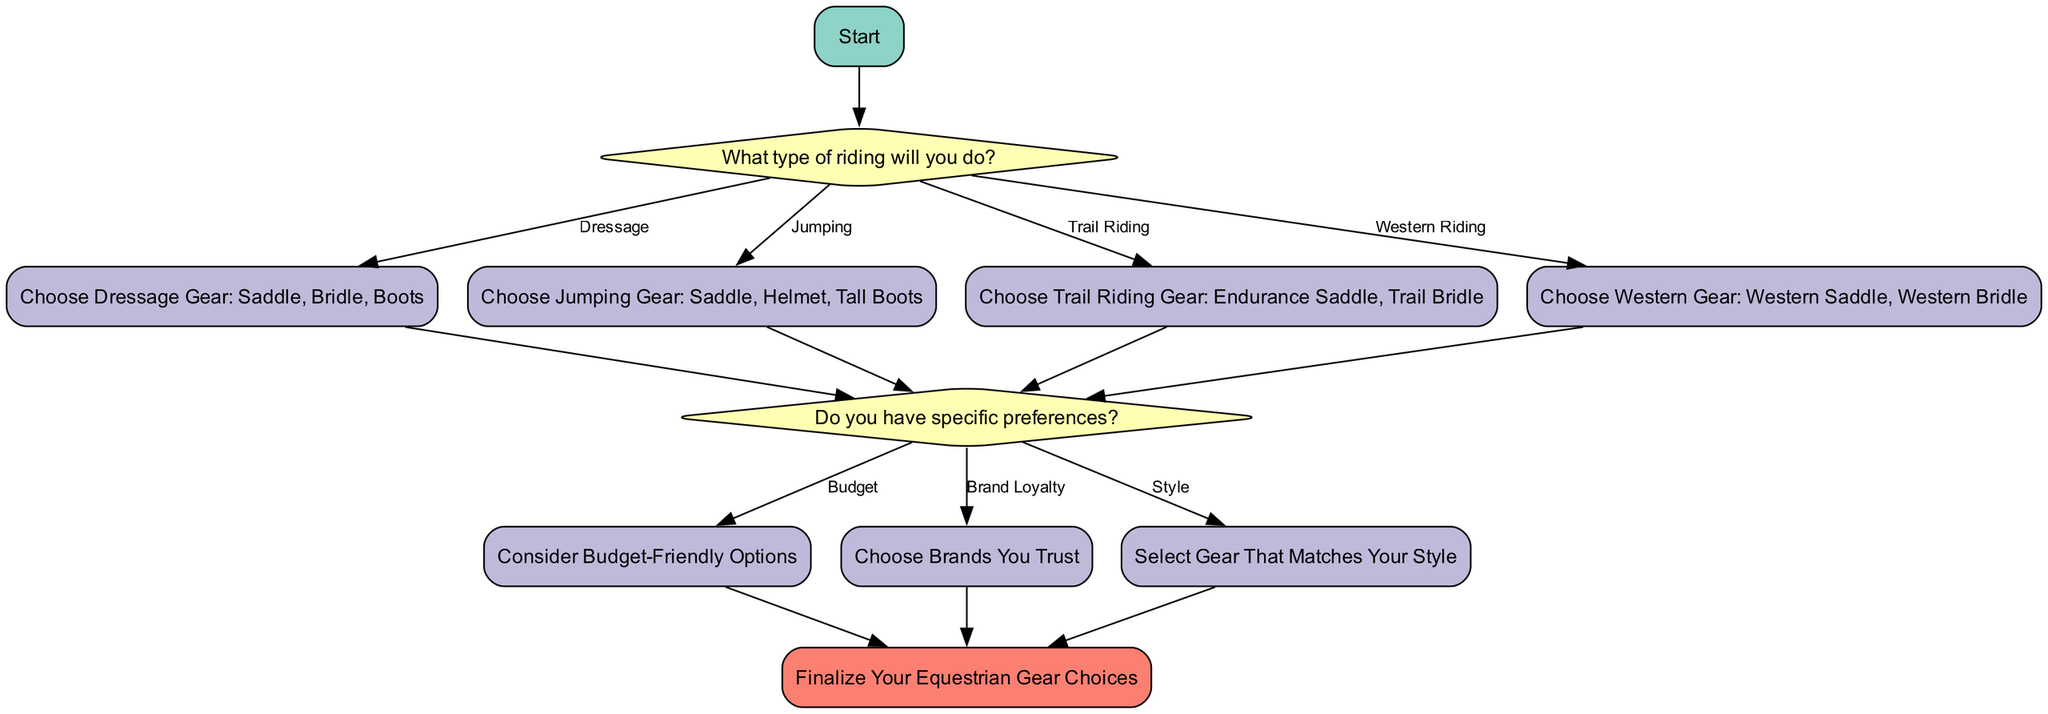What types of riding are identified in the flowchart? The flowchart specifies four types of riding: Dressage, Jumping, Trail Riding, and Western Riding. These are listed as options under the decision node about riding type.
Answer: Dressage, Jumping, Trail Riding, Western Riding What is the first action to take according to the flowchart? The flowchart starts with the "Start" node and then leads to the decision node about what type of riding will be done. Therefore, the first action is to determine the type of riding.
Answer: Determine type of riding How many action nodes are there in the flowchart? The flowchart contains four action nodes: Dressage Gear, Jumping Gear, Trail Riding Gear, Western Gear, Budget-Friendly Options, Brands You Trust, and Gear That Matches Your Style. The total count leads to seven action nodes.
Answer: Seven If a rider chooses Western Riding, what is the next node they will reach? If a rider selects Western Riding, they will move to the action node labeled "Choose Western Gear: Western Saddle, Western Bridle." This follows the path outlined for Western Riding.
Answer: Choose Western Gear: Western Saddle, Western Bridle What factors does the flowchart consider under personal preferences? The flowchart considers three specific factors under personal preferences: Budget, Brand Loyalty, and Style. Each of these factors leads to a different action node for consideration.
Answer: Budget, Brand Loyalty, Style What is the final step after selecting gear preferences? After making selections based on personal preferences, the final step in the flowchart is to "Finalize Your Equestrian Gear Choices," which indicates the completion of the decision-making process.
Answer: Finalize Your Equestrian Gear Choices Which colors are used for decision nodes in the diagram? The decision nodes are represented with a light yellow color (#FFFFB3) according to the color palette defined for the flowchart.
Answer: Light yellow How does a rider move from gear choices to finalizing gear? A rider moves from the gear choices (e.g., Dressage Gear, Jumping Gear, etc.) to the personal preference decisions, and upon making those decisions, they reach the end node titled "Finalize Your Equestrian Gear Choices." This path connects their choices to the final step of the flowchart.
Answer: Through personal preference decisions 